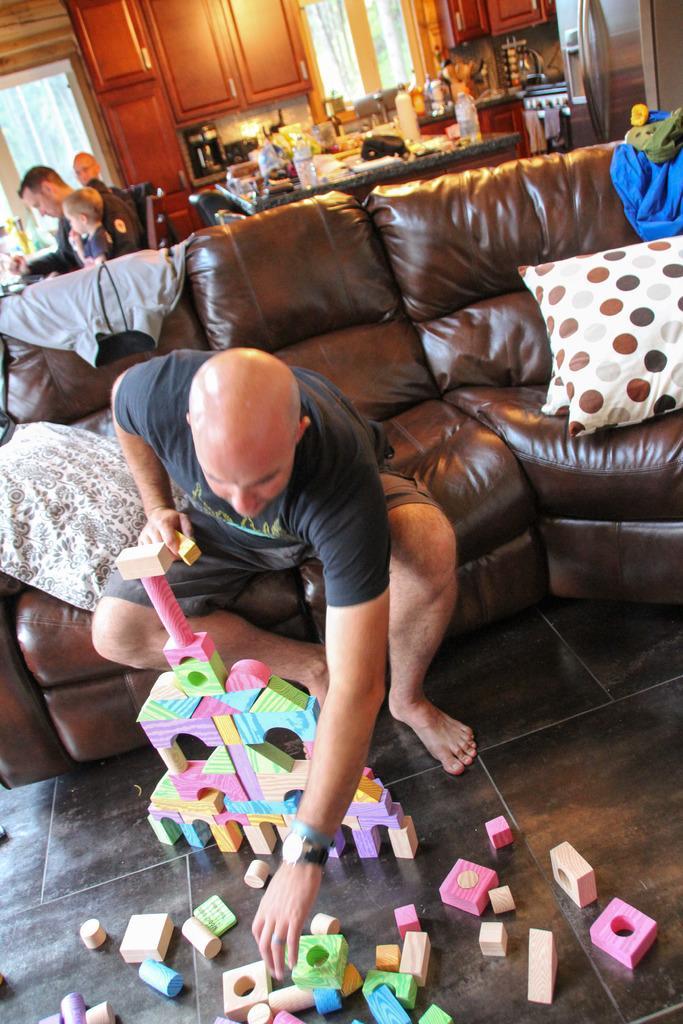How would you summarize this image in a sentence or two? In the picture there is a sofa set, a person is sitting on the sofa set and playing with blocks and behind him there are few people sitting on the chairs and on the right side there is dining table and there are many items kept on the dining table. Beside that there is a refrigerator and there is a kitchen beside the refrigerator and there are many cupboards and two windows in the background. 